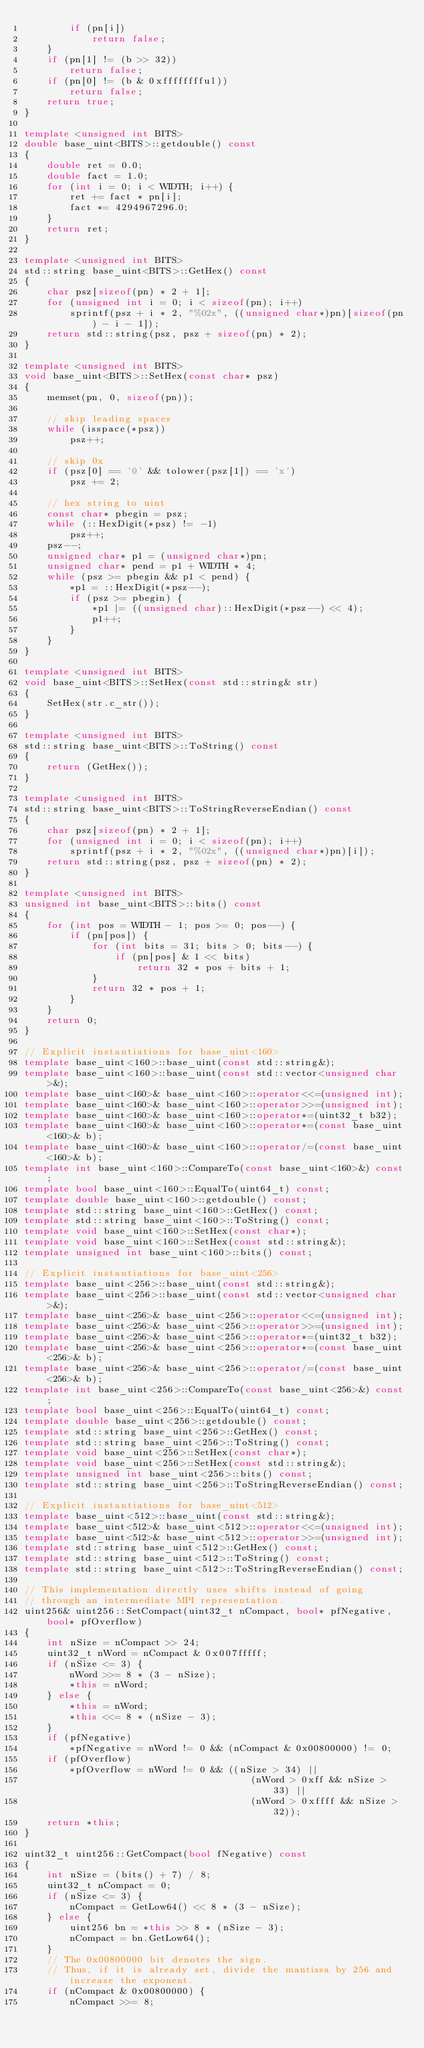<code> <loc_0><loc_0><loc_500><loc_500><_C++_>        if (pn[i])
            return false;
    }
    if (pn[1] != (b >> 32))
        return false;
    if (pn[0] != (b & 0xfffffffful))
        return false;
    return true;
}

template <unsigned int BITS>
double base_uint<BITS>::getdouble() const
{
    double ret = 0.0;
    double fact = 1.0;
    for (int i = 0; i < WIDTH; i++) {
        ret += fact * pn[i];
        fact *= 4294967296.0;
    }
    return ret;
}

template <unsigned int BITS>
std::string base_uint<BITS>::GetHex() const
{
    char psz[sizeof(pn) * 2 + 1];
    for (unsigned int i = 0; i < sizeof(pn); i++)
        sprintf(psz + i * 2, "%02x", ((unsigned char*)pn)[sizeof(pn) - i - 1]);
    return std::string(psz, psz + sizeof(pn) * 2);
}

template <unsigned int BITS>
void base_uint<BITS>::SetHex(const char* psz)
{
    memset(pn, 0, sizeof(pn));

    // skip leading spaces
    while (isspace(*psz))
        psz++;

    // skip 0x
    if (psz[0] == '0' && tolower(psz[1]) == 'x')
        psz += 2;

    // hex string to uint
    const char* pbegin = psz;
    while (::HexDigit(*psz) != -1)
        psz++;
    psz--;
    unsigned char* p1 = (unsigned char*)pn;
    unsigned char* pend = p1 + WIDTH * 4;
    while (psz >= pbegin && p1 < pend) {
        *p1 = ::HexDigit(*psz--);
        if (psz >= pbegin) {
            *p1 |= ((unsigned char)::HexDigit(*psz--) << 4);
            p1++;
        }
    }
}

template <unsigned int BITS>
void base_uint<BITS>::SetHex(const std::string& str)
{
    SetHex(str.c_str());
}

template <unsigned int BITS>
std::string base_uint<BITS>::ToString() const
{
    return (GetHex());
}

template <unsigned int BITS>
std::string base_uint<BITS>::ToStringReverseEndian() const
{
    char psz[sizeof(pn) * 2 + 1];
    for (unsigned int i = 0; i < sizeof(pn); i++)
        sprintf(psz + i * 2, "%02x", ((unsigned char*)pn)[i]);
    return std::string(psz, psz + sizeof(pn) * 2);
}

template <unsigned int BITS>
unsigned int base_uint<BITS>::bits() const
{
    for (int pos = WIDTH - 1; pos >= 0; pos--) {
        if (pn[pos]) {
            for (int bits = 31; bits > 0; bits--) {
                if (pn[pos] & 1 << bits)
                    return 32 * pos + bits + 1;
            }
            return 32 * pos + 1;
        }
    }
    return 0;
}

// Explicit instantiations for base_uint<160>
template base_uint<160>::base_uint(const std::string&);
template base_uint<160>::base_uint(const std::vector<unsigned char>&);
template base_uint<160>& base_uint<160>::operator<<=(unsigned int);
template base_uint<160>& base_uint<160>::operator>>=(unsigned int);
template base_uint<160>& base_uint<160>::operator*=(uint32_t b32);
template base_uint<160>& base_uint<160>::operator*=(const base_uint<160>& b);
template base_uint<160>& base_uint<160>::operator/=(const base_uint<160>& b);
template int base_uint<160>::CompareTo(const base_uint<160>&) const;
template bool base_uint<160>::EqualTo(uint64_t) const;
template double base_uint<160>::getdouble() const;
template std::string base_uint<160>::GetHex() const;
template std::string base_uint<160>::ToString() const;
template void base_uint<160>::SetHex(const char*);
template void base_uint<160>::SetHex(const std::string&);
template unsigned int base_uint<160>::bits() const;

// Explicit instantiations for base_uint<256>
template base_uint<256>::base_uint(const std::string&);
template base_uint<256>::base_uint(const std::vector<unsigned char>&);
template base_uint<256>& base_uint<256>::operator<<=(unsigned int);
template base_uint<256>& base_uint<256>::operator>>=(unsigned int);
template base_uint<256>& base_uint<256>::operator*=(uint32_t b32);
template base_uint<256>& base_uint<256>::operator*=(const base_uint<256>& b);
template base_uint<256>& base_uint<256>::operator/=(const base_uint<256>& b);
template int base_uint<256>::CompareTo(const base_uint<256>&) const;
template bool base_uint<256>::EqualTo(uint64_t) const;
template double base_uint<256>::getdouble() const;
template std::string base_uint<256>::GetHex() const;
template std::string base_uint<256>::ToString() const;
template void base_uint<256>::SetHex(const char*);
template void base_uint<256>::SetHex(const std::string&);
template unsigned int base_uint<256>::bits() const;
template std::string base_uint<256>::ToStringReverseEndian() const;

// Explicit instantiations for base_uint<512>
template base_uint<512>::base_uint(const std::string&);
template base_uint<512>& base_uint<512>::operator<<=(unsigned int);
template base_uint<512>& base_uint<512>::operator>>=(unsigned int);
template std::string base_uint<512>::GetHex() const;
template std::string base_uint<512>::ToString() const;
template std::string base_uint<512>::ToStringReverseEndian() const;

// This implementation directly uses shifts instead of going
// through an intermediate MPI representation.
uint256& uint256::SetCompact(uint32_t nCompact, bool* pfNegative, bool* pfOverflow)
{
    int nSize = nCompact >> 24;
    uint32_t nWord = nCompact & 0x007fffff;
    if (nSize <= 3) {
        nWord >>= 8 * (3 - nSize);
        *this = nWord;
    } else {
        *this = nWord;
        *this <<= 8 * (nSize - 3);
    }
    if (pfNegative)
        *pfNegative = nWord != 0 && (nCompact & 0x00800000) != 0;
    if (pfOverflow)
        *pfOverflow = nWord != 0 && ((nSize > 34) ||
                                        (nWord > 0xff && nSize > 33) ||
                                        (nWord > 0xffff && nSize > 32));
    return *this;
}

uint32_t uint256::GetCompact(bool fNegative) const
{
    int nSize = (bits() + 7) / 8;
    uint32_t nCompact = 0;
    if (nSize <= 3) {
        nCompact = GetLow64() << 8 * (3 - nSize);
    } else {
        uint256 bn = *this >> 8 * (nSize - 3);
        nCompact = bn.GetLow64();
    }
    // The 0x00800000 bit denotes the sign.
    // Thus, if it is already set, divide the mantissa by 256 and increase the exponent.
    if (nCompact & 0x00800000) {
        nCompact >>= 8;</code> 